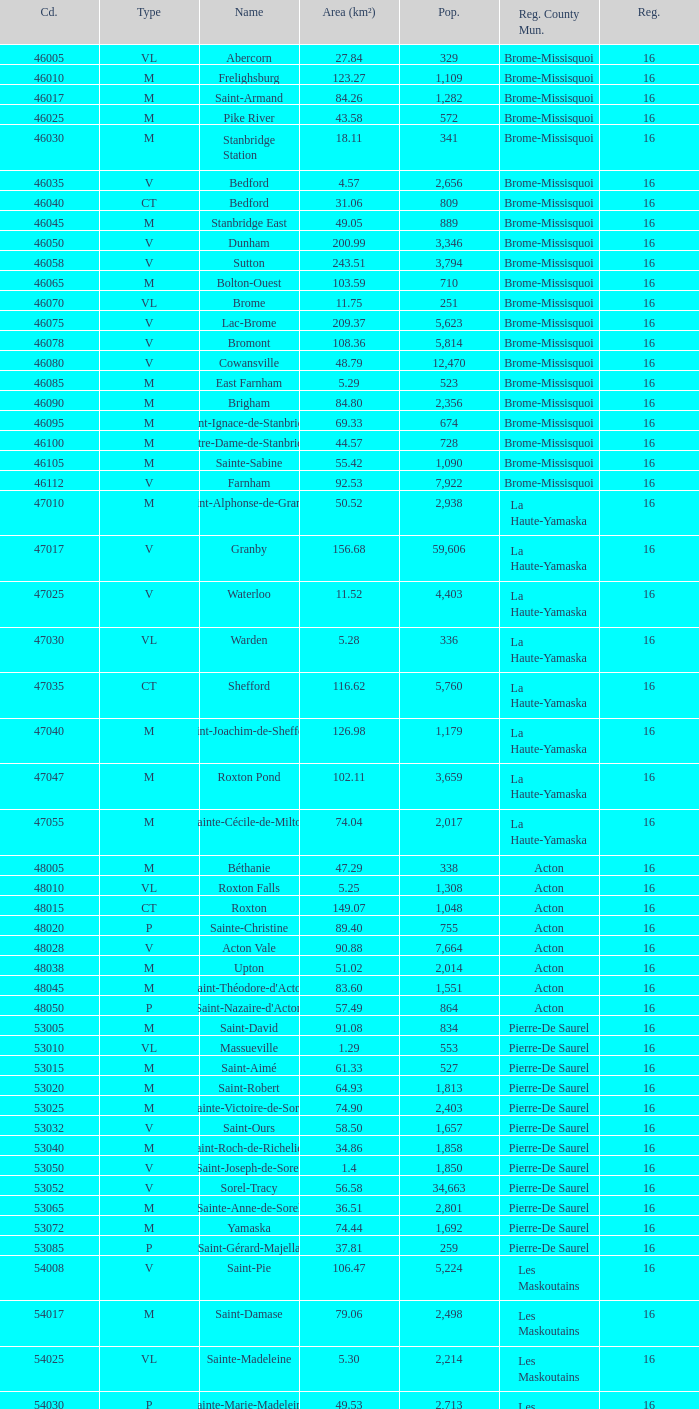Saint-Blaise-Sur-Richelieu is smaller than 68.42 km^2, what is the population of this type M municipality? None. 